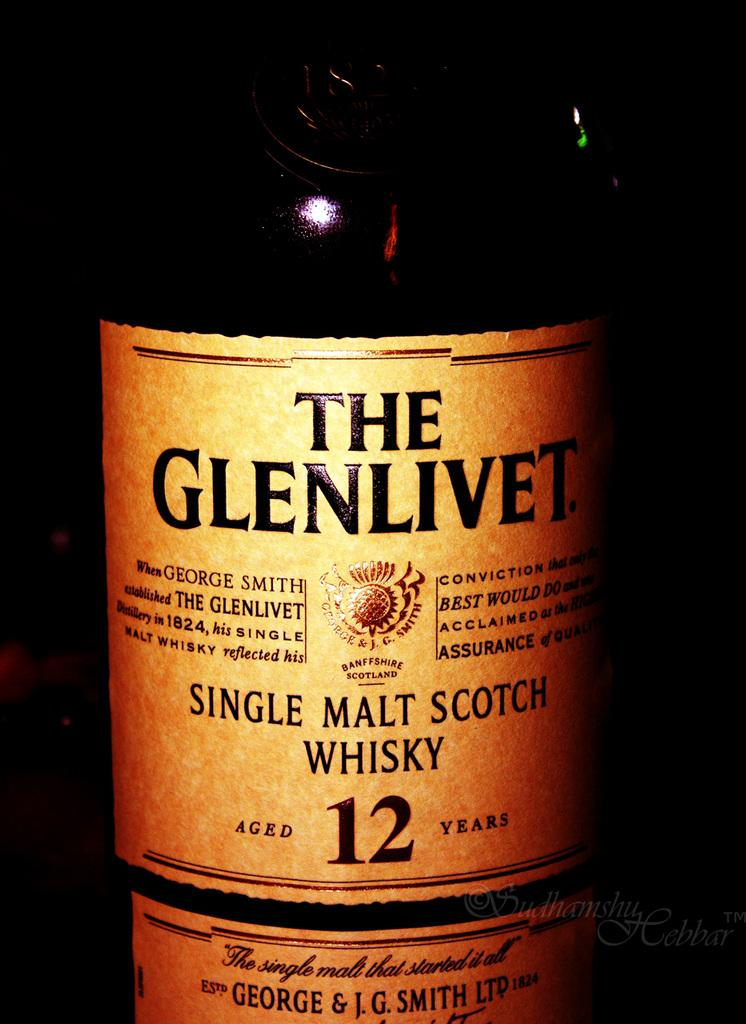<image>
Summarize the visual content of the image. A whisky label advertises that it has been aged twelve years. 